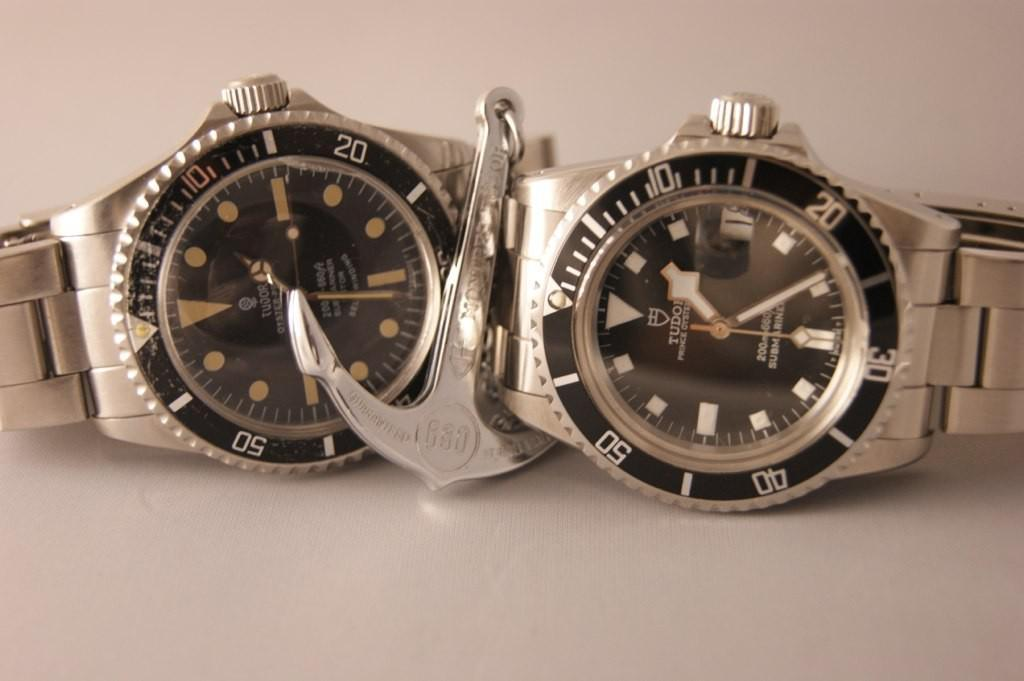<image>
Write a terse but informative summary of the picture. Two Tudor watches with a silver anchor in between. 